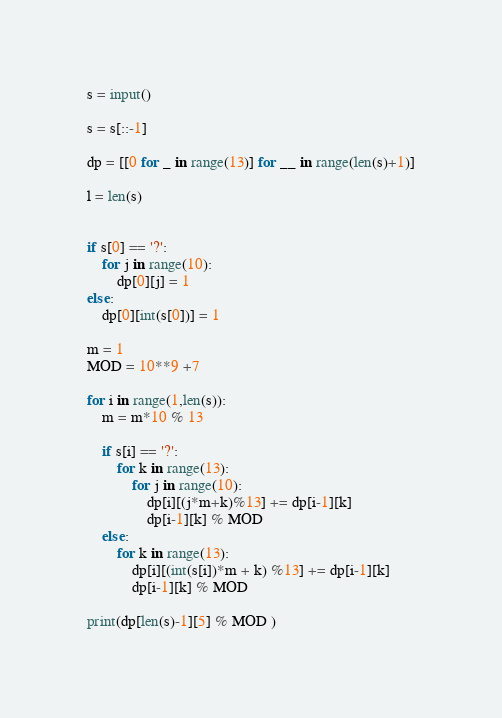Convert code to text. <code><loc_0><loc_0><loc_500><loc_500><_Python_>s = input()

s = s[::-1]

dp = [[0 for _ in range(13)] for __ in range(len(s)+1)]

l = len(s)


if s[0] == '?':
    for j in range(10):
        dp[0][j] = 1
else:
    dp[0][int(s[0])] = 1

m = 1
MOD = 10**9 +7

for i in range(1,len(s)):
    m = m*10 % 13

    if s[i] == '?':
        for k in range(13):
            for j in range(10):
                dp[i][(j*m+k)%13] += dp[i-1][k]
                dp[i-1][k] % MOD
    else:
        for k in range(13):
            dp[i][(int(s[i])*m + k) %13] += dp[i-1][k]
            dp[i-1][k] % MOD

print(dp[len(s)-1][5] % MOD )</code> 